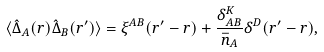Convert formula to latex. <formula><loc_0><loc_0><loc_500><loc_500>\langle \hat { \Delta } _ { A } ( r ) \hat { \Delta } _ { B } ( r ^ { \prime } ) \rangle = \xi ^ { A B } ( r ^ { \prime } - r ) + \frac { \delta ^ { K } _ { A B } } { \bar { n } _ { A } } \delta ^ { D } ( r ^ { \prime } - r ) ,</formula> 